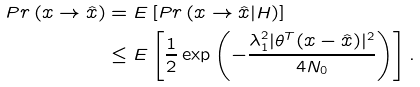<formula> <loc_0><loc_0><loc_500><loc_500>P r \left ( x \rightarrow \hat { x } \right ) & = E \left [ P r \left ( x \rightarrow \hat { x } | H \right ) \right ] \\ & \leq E \left [ \frac { 1 } { 2 } \exp \left ( - \frac { \lambda _ { 1 } ^ { 2 } | \theta ^ { T } ( x - \hat { x } ) | ^ { 2 } } { 4 N _ { 0 } } \right ) \right ] .</formula> 